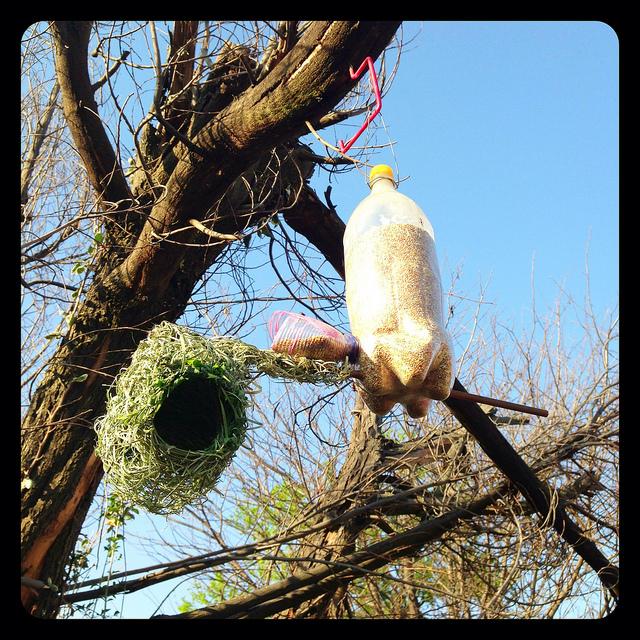What is the green thing?
Be succinct. Nest. What is in the plastic bottle?
Short answer required. Bird seed. Is a bird on the tree branch?
Short answer required. No. 